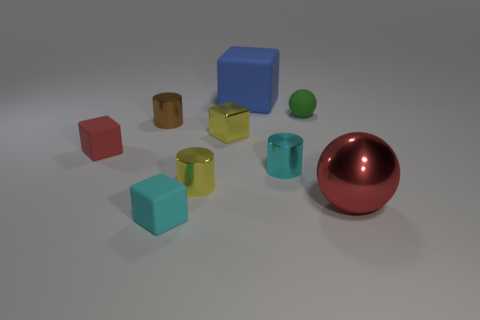There is a matte object on the left side of the cyan cube; what color is it?
Keep it short and to the point. Red. The tiny brown shiny object is what shape?
Give a very brief answer. Cylinder. What material is the tiny cylinder in front of the cyan object to the right of the large blue thing?
Provide a short and direct response. Metal. How many other objects are there of the same material as the large blue object?
Offer a very short reply. 3. There is a brown thing that is the same size as the metallic cube; what is it made of?
Provide a short and direct response. Metal. Is the number of matte spheres that are in front of the cyan matte cube greater than the number of large blue rubber objects that are right of the blue object?
Give a very brief answer. No. Is there a small red object of the same shape as the cyan matte object?
Make the answer very short. Yes. The red matte object that is the same size as the brown metal cylinder is what shape?
Offer a very short reply. Cube. What is the shape of the yellow thing that is behind the red block?
Provide a short and direct response. Cube. Is the number of rubber spheres that are behind the big blue rubber object less than the number of red rubber cubes that are in front of the tiny yellow cylinder?
Your answer should be very brief. No. 